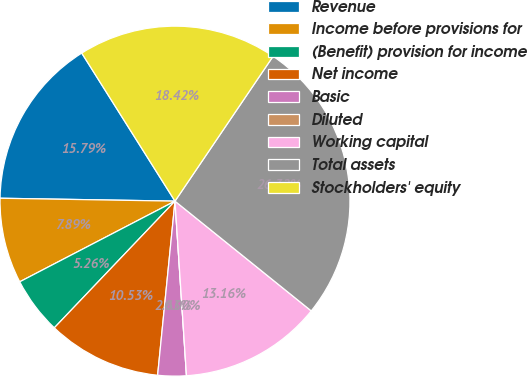<chart> <loc_0><loc_0><loc_500><loc_500><pie_chart><fcel>Revenue<fcel>Income before provisions for<fcel>(Benefit) provision for income<fcel>Net income<fcel>Basic<fcel>Diluted<fcel>Working capital<fcel>Total assets<fcel>Stockholders' equity<nl><fcel>15.79%<fcel>7.89%<fcel>5.26%<fcel>10.53%<fcel>2.63%<fcel>0.0%<fcel>13.16%<fcel>26.32%<fcel>18.42%<nl></chart> 